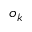Convert formula to latex. <formula><loc_0><loc_0><loc_500><loc_500>o _ { k }</formula> 